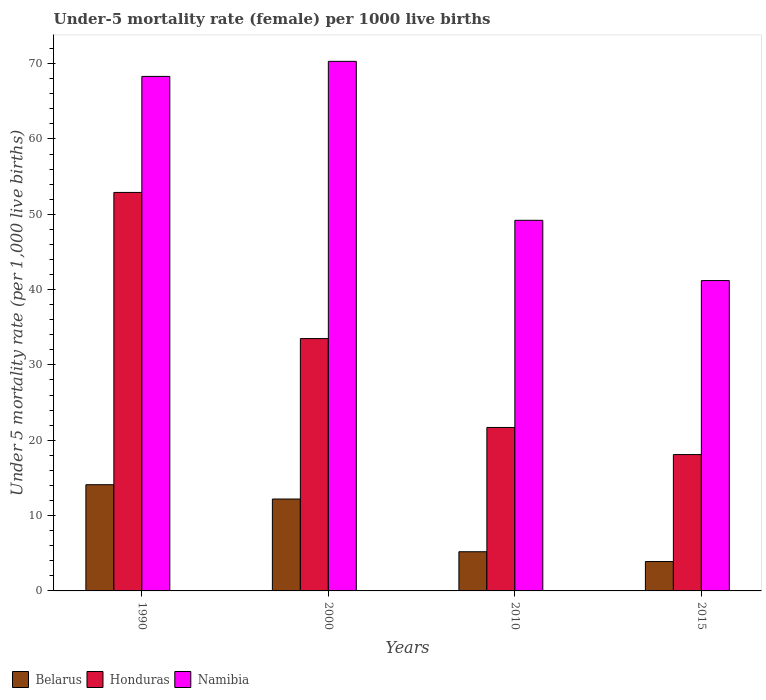How many groups of bars are there?
Provide a succinct answer. 4. Are the number of bars per tick equal to the number of legend labels?
Your answer should be compact. Yes. Are the number of bars on each tick of the X-axis equal?
Your response must be concise. Yes. How many bars are there on the 1st tick from the right?
Your response must be concise. 3. What is the label of the 2nd group of bars from the left?
Make the answer very short. 2000. In how many cases, is the number of bars for a given year not equal to the number of legend labels?
Ensure brevity in your answer.  0. Across all years, what is the maximum under-five mortality rate in Namibia?
Give a very brief answer. 70.3. In which year was the under-five mortality rate in Honduras maximum?
Ensure brevity in your answer.  1990. In which year was the under-five mortality rate in Honduras minimum?
Your response must be concise. 2015. What is the total under-five mortality rate in Honduras in the graph?
Your answer should be very brief. 126.2. What is the difference between the under-five mortality rate in Honduras in 1990 and that in 2015?
Make the answer very short. 34.8. What is the difference between the under-five mortality rate in Namibia in 2000 and the under-five mortality rate in Belarus in 2010?
Your answer should be compact. 65.1. What is the average under-five mortality rate in Namibia per year?
Provide a short and direct response. 57.25. In the year 2010, what is the difference between the under-five mortality rate in Honduras and under-five mortality rate in Namibia?
Offer a terse response. -27.5. What is the ratio of the under-five mortality rate in Belarus in 1990 to that in 2000?
Keep it short and to the point. 1.16. What is the difference between the highest and the second highest under-five mortality rate in Namibia?
Make the answer very short. 2. What is the difference between the highest and the lowest under-five mortality rate in Honduras?
Offer a very short reply. 34.8. What does the 3rd bar from the left in 2015 represents?
Offer a very short reply. Namibia. What does the 2nd bar from the right in 1990 represents?
Your response must be concise. Honduras. How many years are there in the graph?
Your answer should be very brief. 4. What is the difference between two consecutive major ticks on the Y-axis?
Ensure brevity in your answer.  10. Are the values on the major ticks of Y-axis written in scientific E-notation?
Make the answer very short. No. Does the graph contain grids?
Keep it short and to the point. No. How many legend labels are there?
Make the answer very short. 3. What is the title of the graph?
Ensure brevity in your answer.  Under-5 mortality rate (female) per 1000 live births. Does "Kosovo" appear as one of the legend labels in the graph?
Your answer should be very brief. No. What is the label or title of the X-axis?
Your response must be concise. Years. What is the label or title of the Y-axis?
Your answer should be very brief. Under 5 mortality rate (per 1,0 live births). What is the Under 5 mortality rate (per 1,000 live births) of Honduras in 1990?
Your response must be concise. 52.9. What is the Under 5 mortality rate (per 1,000 live births) in Namibia in 1990?
Your answer should be compact. 68.3. What is the Under 5 mortality rate (per 1,000 live births) in Belarus in 2000?
Your answer should be very brief. 12.2. What is the Under 5 mortality rate (per 1,000 live births) of Honduras in 2000?
Your answer should be compact. 33.5. What is the Under 5 mortality rate (per 1,000 live births) of Namibia in 2000?
Give a very brief answer. 70.3. What is the Under 5 mortality rate (per 1,000 live births) of Honduras in 2010?
Give a very brief answer. 21.7. What is the Under 5 mortality rate (per 1,000 live births) in Namibia in 2010?
Offer a terse response. 49.2. What is the Under 5 mortality rate (per 1,000 live births) of Namibia in 2015?
Offer a terse response. 41.2. Across all years, what is the maximum Under 5 mortality rate (per 1,000 live births) of Honduras?
Offer a very short reply. 52.9. Across all years, what is the maximum Under 5 mortality rate (per 1,000 live births) of Namibia?
Your response must be concise. 70.3. Across all years, what is the minimum Under 5 mortality rate (per 1,000 live births) of Belarus?
Provide a succinct answer. 3.9. Across all years, what is the minimum Under 5 mortality rate (per 1,000 live births) in Namibia?
Keep it short and to the point. 41.2. What is the total Under 5 mortality rate (per 1,000 live births) of Belarus in the graph?
Give a very brief answer. 35.4. What is the total Under 5 mortality rate (per 1,000 live births) of Honduras in the graph?
Your answer should be compact. 126.2. What is the total Under 5 mortality rate (per 1,000 live births) of Namibia in the graph?
Provide a short and direct response. 229. What is the difference between the Under 5 mortality rate (per 1,000 live births) of Belarus in 1990 and that in 2000?
Ensure brevity in your answer.  1.9. What is the difference between the Under 5 mortality rate (per 1,000 live births) in Honduras in 1990 and that in 2010?
Keep it short and to the point. 31.2. What is the difference between the Under 5 mortality rate (per 1,000 live births) in Belarus in 1990 and that in 2015?
Provide a succinct answer. 10.2. What is the difference between the Under 5 mortality rate (per 1,000 live births) of Honduras in 1990 and that in 2015?
Offer a very short reply. 34.8. What is the difference between the Under 5 mortality rate (per 1,000 live births) in Namibia in 1990 and that in 2015?
Your answer should be compact. 27.1. What is the difference between the Under 5 mortality rate (per 1,000 live births) in Belarus in 2000 and that in 2010?
Offer a very short reply. 7. What is the difference between the Under 5 mortality rate (per 1,000 live births) in Namibia in 2000 and that in 2010?
Keep it short and to the point. 21.1. What is the difference between the Under 5 mortality rate (per 1,000 live births) of Belarus in 2000 and that in 2015?
Your answer should be compact. 8.3. What is the difference between the Under 5 mortality rate (per 1,000 live births) in Honduras in 2000 and that in 2015?
Ensure brevity in your answer.  15.4. What is the difference between the Under 5 mortality rate (per 1,000 live births) of Namibia in 2000 and that in 2015?
Give a very brief answer. 29.1. What is the difference between the Under 5 mortality rate (per 1,000 live births) in Honduras in 2010 and that in 2015?
Your answer should be compact. 3.6. What is the difference between the Under 5 mortality rate (per 1,000 live births) in Namibia in 2010 and that in 2015?
Keep it short and to the point. 8. What is the difference between the Under 5 mortality rate (per 1,000 live births) in Belarus in 1990 and the Under 5 mortality rate (per 1,000 live births) in Honduras in 2000?
Ensure brevity in your answer.  -19.4. What is the difference between the Under 5 mortality rate (per 1,000 live births) of Belarus in 1990 and the Under 5 mortality rate (per 1,000 live births) of Namibia in 2000?
Provide a short and direct response. -56.2. What is the difference between the Under 5 mortality rate (per 1,000 live births) in Honduras in 1990 and the Under 5 mortality rate (per 1,000 live births) in Namibia in 2000?
Offer a very short reply. -17.4. What is the difference between the Under 5 mortality rate (per 1,000 live births) in Belarus in 1990 and the Under 5 mortality rate (per 1,000 live births) in Namibia in 2010?
Your answer should be compact. -35.1. What is the difference between the Under 5 mortality rate (per 1,000 live births) in Belarus in 1990 and the Under 5 mortality rate (per 1,000 live births) in Namibia in 2015?
Offer a terse response. -27.1. What is the difference between the Under 5 mortality rate (per 1,000 live births) in Belarus in 2000 and the Under 5 mortality rate (per 1,000 live births) in Namibia in 2010?
Your answer should be very brief. -37. What is the difference between the Under 5 mortality rate (per 1,000 live births) in Honduras in 2000 and the Under 5 mortality rate (per 1,000 live births) in Namibia in 2010?
Give a very brief answer. -15.7. What is the difference between the Under 5 mortality rate (per 1,000 live births) of Belarus in 2000 and the Under 5 mortality rate (per 1,000 live births) of Honduras in 2015?
Keep it short and to the point. -5.9. What is the difference between the Under 5 mortality rate (per 1,000 live births) of Honduras in 2000 and the Under 5 mortality rate (per 1,000 live births) of Namibia in 2015?
Offer a terse response. -7.7. What is the difference between the Under 5 mortality rate (per 1,000 live births) of Belarus in 2010 and the Under 5 mortality rate (per 1,000 live births) of Namibia in 2015?
Give a very brief answer. -36. What is the difference between the Under 5 mortality rate (per 1,000 live births) of Honduras in 2010 and the Under 5 mortality rate (per 1,000 live births) of Namibia in 2015?
Provide a short and direct response. -19.5. What is the average Under 5 mortality rate (per 1,000 live births) of Belarus per year?
Offer a very short reply. 8.85. What is the average Under 5 mortality rate (per 1,000 live births) in Honduras per year?
Your answer should be compact. 31.55. What is the average Under 5 mortality rate (per 1,000 live births) in Namibia per year?
Give a very brief answer. 57.25. In the year 1990, what is the difference between the Under 5 mortality rate (per 1,000 live births) in Belarus and Under 5 mortality rate (per 1,000 live births) in Honduras?
Make the answer very short. -38.8. In the year 1990, what is the difference between the Under 5 mortality rate (per 1,000 live births) of Belarus and Under 5 mortality rate (per 1,000 live births) of Namibia?
Your response must be concise. -54.2. In the year 1990, what is the difference between the Under 5 mortality rate (per 1,000 live births) of Honduras and Under 5 mortality rate (per 1,000 live births) of Namibia?
Give a very brief answer. -15.4. In the year 2000, what is the difference between the Under 5 mortality rate (per 1,000 live births) in Belarus and Under 5 mortality rate (per 1,000 live births) in Honduras?
Give a very brief answer. -21.3. In the year 2000, what is the difference between the Under 5 mortality rate (per 1,000 live births) in Belarus and Under 5 mortality rate (per 1,000 live births) in Namibia?
Your answer should be compact. -58.1. In the year 2000, what is the difference between the Under 5 mortality rate (per 1,000 live births) in Honduras and Under 5 mortality rate (per 1,000 live births) in Namibia?
Provide a short and direct response. -36.8. In the year 2010, what is the difference between the Under 5 mortality rate (per 1,000 live births) of Belarus and Under 5 mortality rate (per 1,000 live births) of Honduras?
Give a very brief answer. -16.5. In the year 2010, what is the difference between the Under 5 mortality rate (per 1,000 live births) in Belarus and Under 5 mortality rate (per 1,000 live births) in Namibia?
Provide a succinct answer. -44. In the year 2010, what is the difference between the Under 5 mortality rate (per 1,000 live births) of Honduras and Under 5 mortality rate (per 1,000 live births) of Namibia?
Provide a succinct answer. -27.5. In the year 2015, what is the difference between the Under 5 mortality rate (per 1,000 live births) in Belarus and Under 5 mortality rate (per 1,000 live births) in Honduras?
Give a very brief answer. -14.2. In the year 2015, what is the difference between the Under 5 mortality rate (per 1,000 live births) of Belarus and Under 5 mortality rate (per 1,000 live births) of Namibia?
Your answer should be compact. -37.3. In the year 2015, what is the difference between the Under 5 mortality rate (per 1,000 live births) in Honduras and Under 5 mortality rate (per 1,000 live births) in Namibia?
Your response must be concise. -23.1. What is the ratio of the Under 5 mortality rate (per 1,000 live births) in Belarus in 1990 to that in 2000?
Provide a short and direct response. 1.16. What is the ratio of the Under 5 mortality rate (per 1,000 live births) of Honduras in 1990 to that in 2000?
Ensure brevity in your answer.  1.58. What is the ratio of the Under 5 mortality rate (per 1,000 live births) of Namibia in 1990 to that in 2000?
Make the answer very short. 0.97. What is the ratio of the Under 5 mortality rate (per 1,000 live births) in Belarus in 1990 to that in 2010?
Ensure brevity in your answer.  2.71. What is the ratio of the Under 5 mortality rate (per 1,000 live births) in Honduras in 1990 to that in 2010?
Offer a very short reply. 2.44. What is the ratio of the Under 5 mortality rate (per 1,000 live births) in Namibia in 1990 to that in 2010?
Ensure brevity in your answer.  1.39. What is the ratio of the Under 5 mortality rate (per 1,000 live births) in Belarus in 1990 to that in 2015?
Ensure brevity in your answer.  3.62. What is the ratio of the Under 5 mortality rate (per 1,000 live births) in Honduras in 1990 to that in 2015?
Make the answer very short. 2.92. What is the ratio of the Under 5 mortality rate (per 1,000 live births) of Namibia in 1990 to that in 2015?
Offer a terse response. 1.66. What is the ratio of the Under 5 mortality rate (per 1,000 live births) of Belarus in 2000 to that in 2010?
Provide a short and direct response. 2.35. What is the ratio of the Under 5 mortality rate (per 1,000 live births) of Honduras in 2000 to that in 2010?
Provide a succinct answer. 1.54. What is the ratio of the Under 5 mortality rate (per 1,000 live births) in Namibia in 2000 to that in 2010?
Ensure brevity in your answer.  1.43. What is the ratio of the Under 5 mortality rate (per 1,000 live births) in Belarus in 2000 to that in 2015?
Provide a succinct answer. 3.13. What is the ratio of the Under 5 mortality rate (per 1,000 live births) in Honduras in 2000 to that in 2015?
Your answer should be very brief. 1.85. What is the ratio of the Under 5 mortality rate (per 1,000 live births) in Namibia in 2000 to that in 2015?
Keep it short and to the point. 1.71. What is the ratio of the Under 5 mortality rate (per 1,000 live births) in Honduras in 2010 to that in 2015?
Your answer should be very brief. 1.2. What is the ratio of the Under 5 mortality rate (per 1,000 live births) in Namibia in 2010 to that in 2015?
Your answer should be compact. 1.19. What is the difference between the highest and the second highest Under 5 mortality rate (per 1,000 live births) in Namibia?
Your response must be concise. 2. What is the difference between the highest and the lowest Under 5 mortality rate (per 1,000 live births) of Honduras?
Your response must be concise. 34.8. What is the difference between the highest and the lowest Under 5 mortality rate (per 1,000 live births) of Namibia?
Provide a short and direct response. 29.1. 